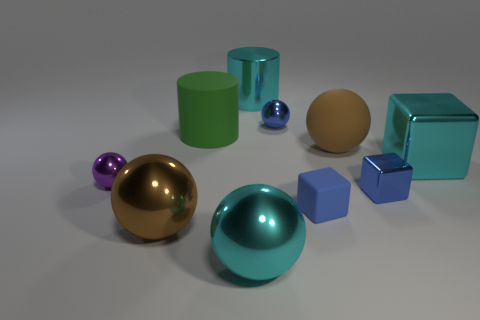What function might these objects serve if they were in a real-world setting? In a real-world setting, these objects might serve various purposes depending on their material and stability. The spheres could be decorative elements or could be used in games like ball sports, while the cubes might serve as building blocks or weights. How might lighting affect the appearance of these objects? Lighting can significantly affect these objects' appearance by highlighting their textures and creating reflections. Materials with glossy finishes would reflect light and create highlights, while matte surfaces would absorb light and cast more diffuse shadows. 